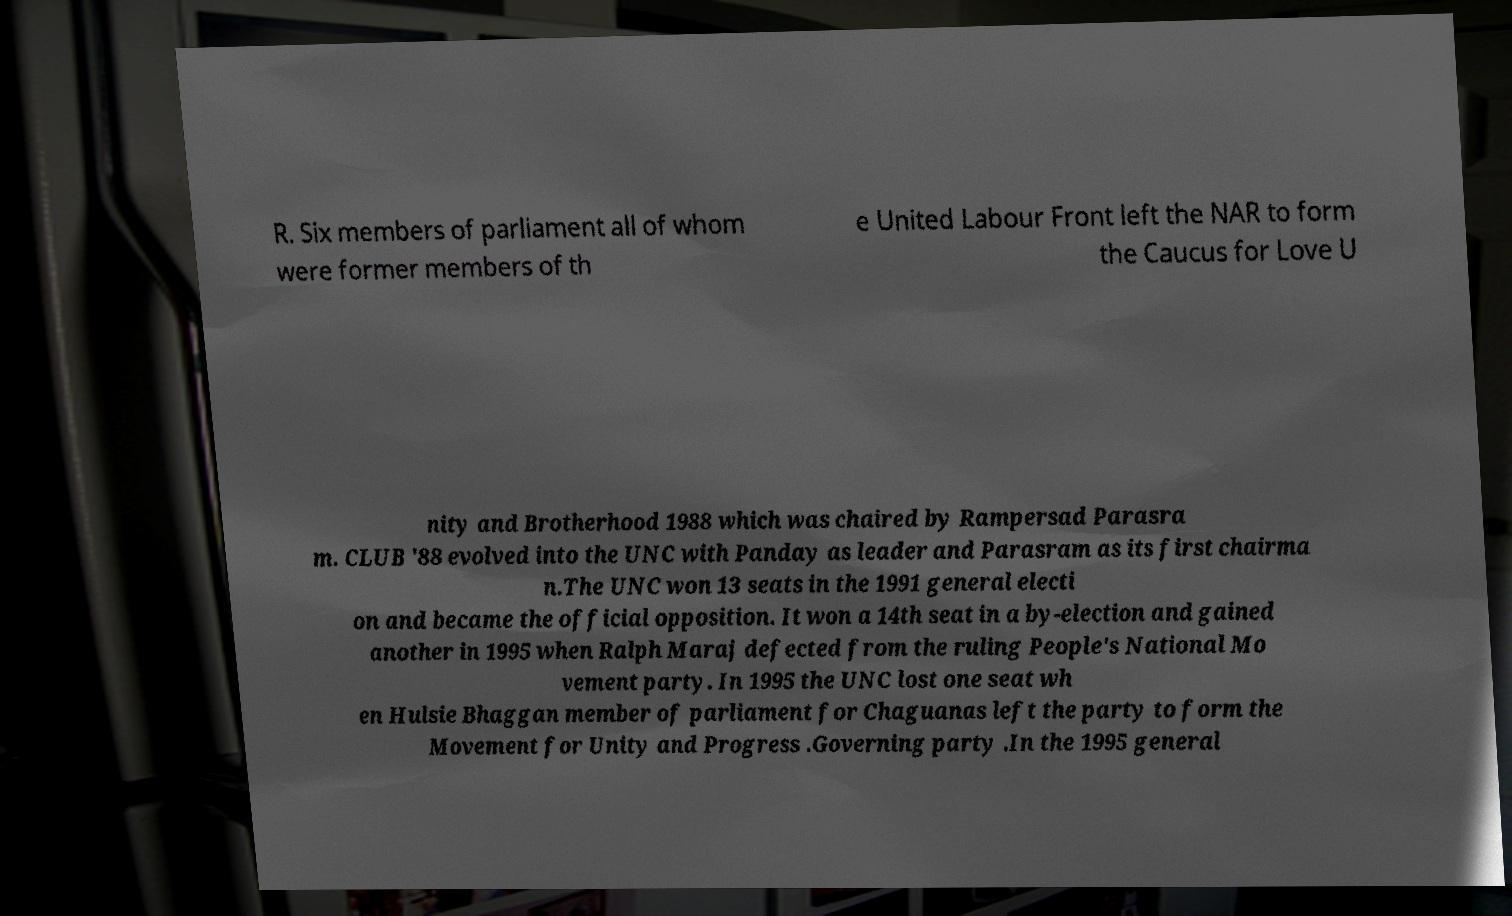There's text embedded in this image that I need extracted. Can you transcribe it verbatim? R. Six members of parliament all of whom were former members of th e United Labour Front left the NAR to form the Caucus for Love U nity and Brotherhood 1988 which was chaired by Rampersad Parasra m. CLUB '88 evolved into the UNC with Panday as leader and Parasram as its first chairma n.The UNC won 13 seats in the 1991 general electi on and became the official opposition. It won a 14th seat in a by-election and gained another in 1995 when Ralph Maraj defected from the ruling People's National Mo vement party. In 1995 the UNC lost one seat wh en Hulsie Bhaggan member of parliament for Chaguanas left the party to form the Movement for Unity and Progress .Governing party .In the 1995 general 